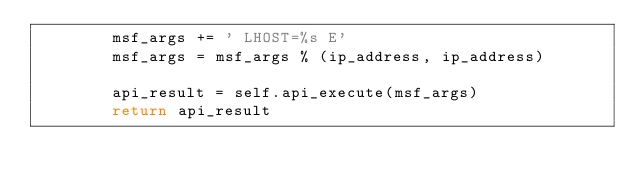Convert code to text. <code><loc_0><loc_0><loc_500><loc_500><_Python_>        msf_args += ' LHOST=%s E'
        msf_args = msf_args % (ip_address, ip_address)

        api_result = self.api_execute(msf_args)
        return api_result
</code> 